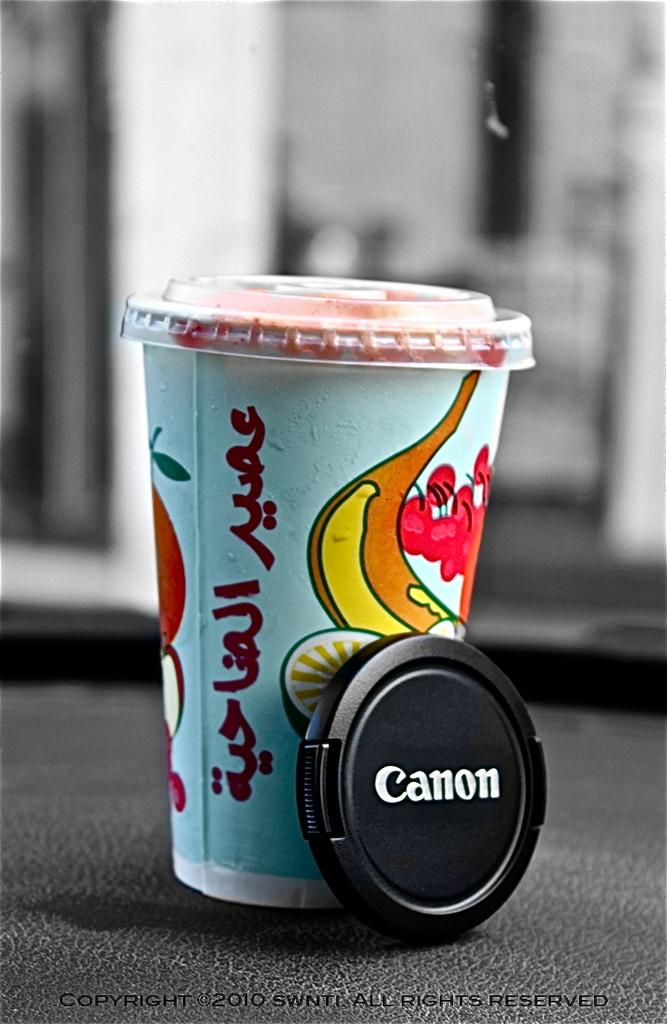What type of container is visible in the image? There is a disposable glass in the image. What can be seen in the background of the image? There is a window in the background of the image. What type of sweater is being worn by the loaf in the image? There is no sweater or loaf present in the image; it only features a disposable glass and a window in the background. 